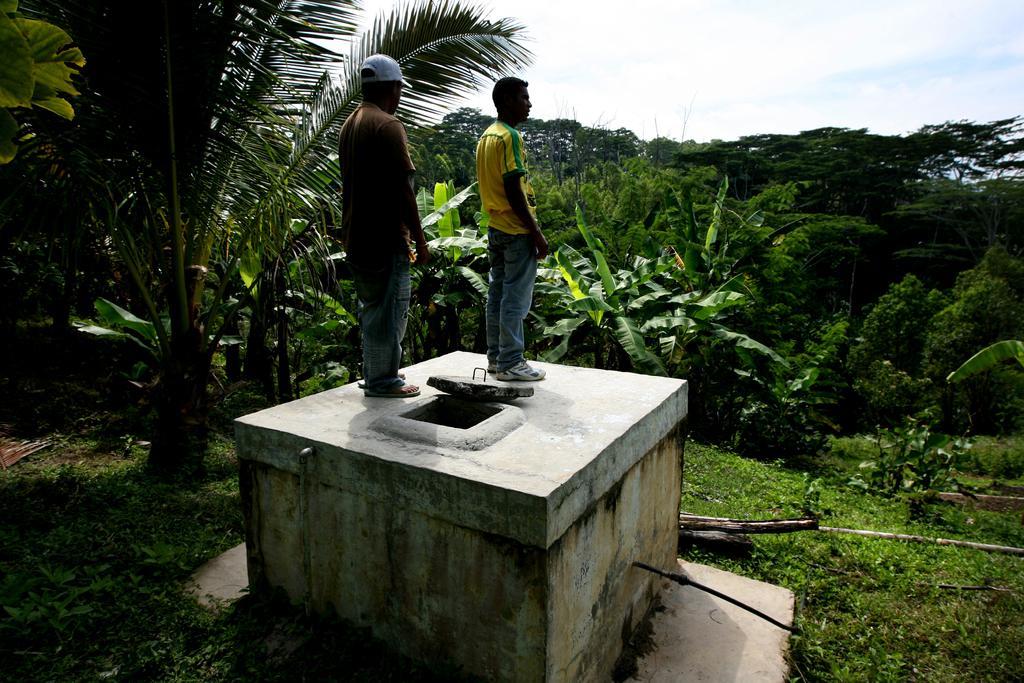Can you describe this image briefly? In this picture I can see couple of them on the tank and I can see trees and grass on the ground and I can see a blue cloudy sky. 